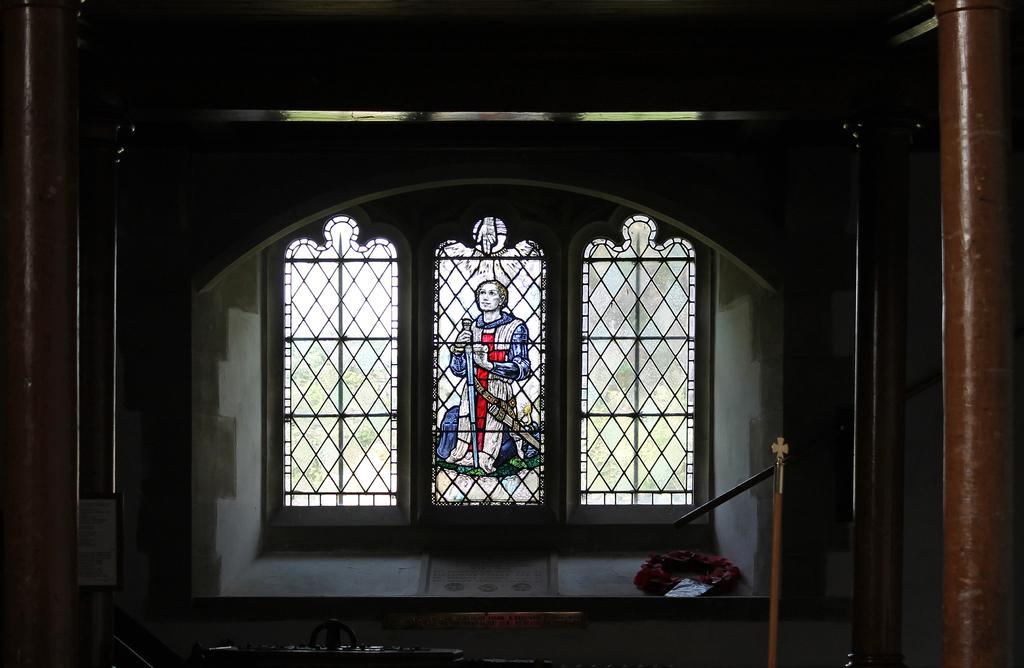What architectural feature is located on the left side of the image? There is a pillar of a building on the left side of the image. Is there a similar feature on the other side of the image? Yes, there is another pillar on the right side of the image. What can be seen in the background of the image? There is a painting on a glass window and a white wall in the background of the image. How many babies are crawling on the pillar on the right side of the image? There are no babies present in the image; it only features pillars and a painting on a glass window in the background. 